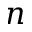<formula> <loc_0><loc_0><loc_500><loc_500>n</formula> 